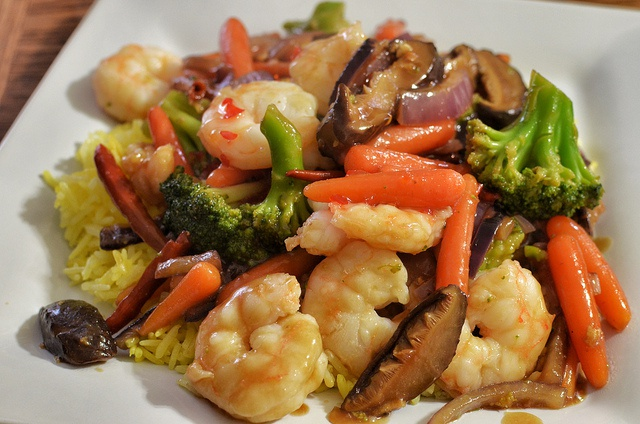Describe the objects in this image and their specific colors. I can see broccoli in salmon, olive, and black tones, broccoli in salmon, black, olive, and maroon tones, dining table in salmon, brown, and maroon tones, carrot in salmon, red, brown, and maroon tones, and carrot in salmon, red, and brown tones in this image. 